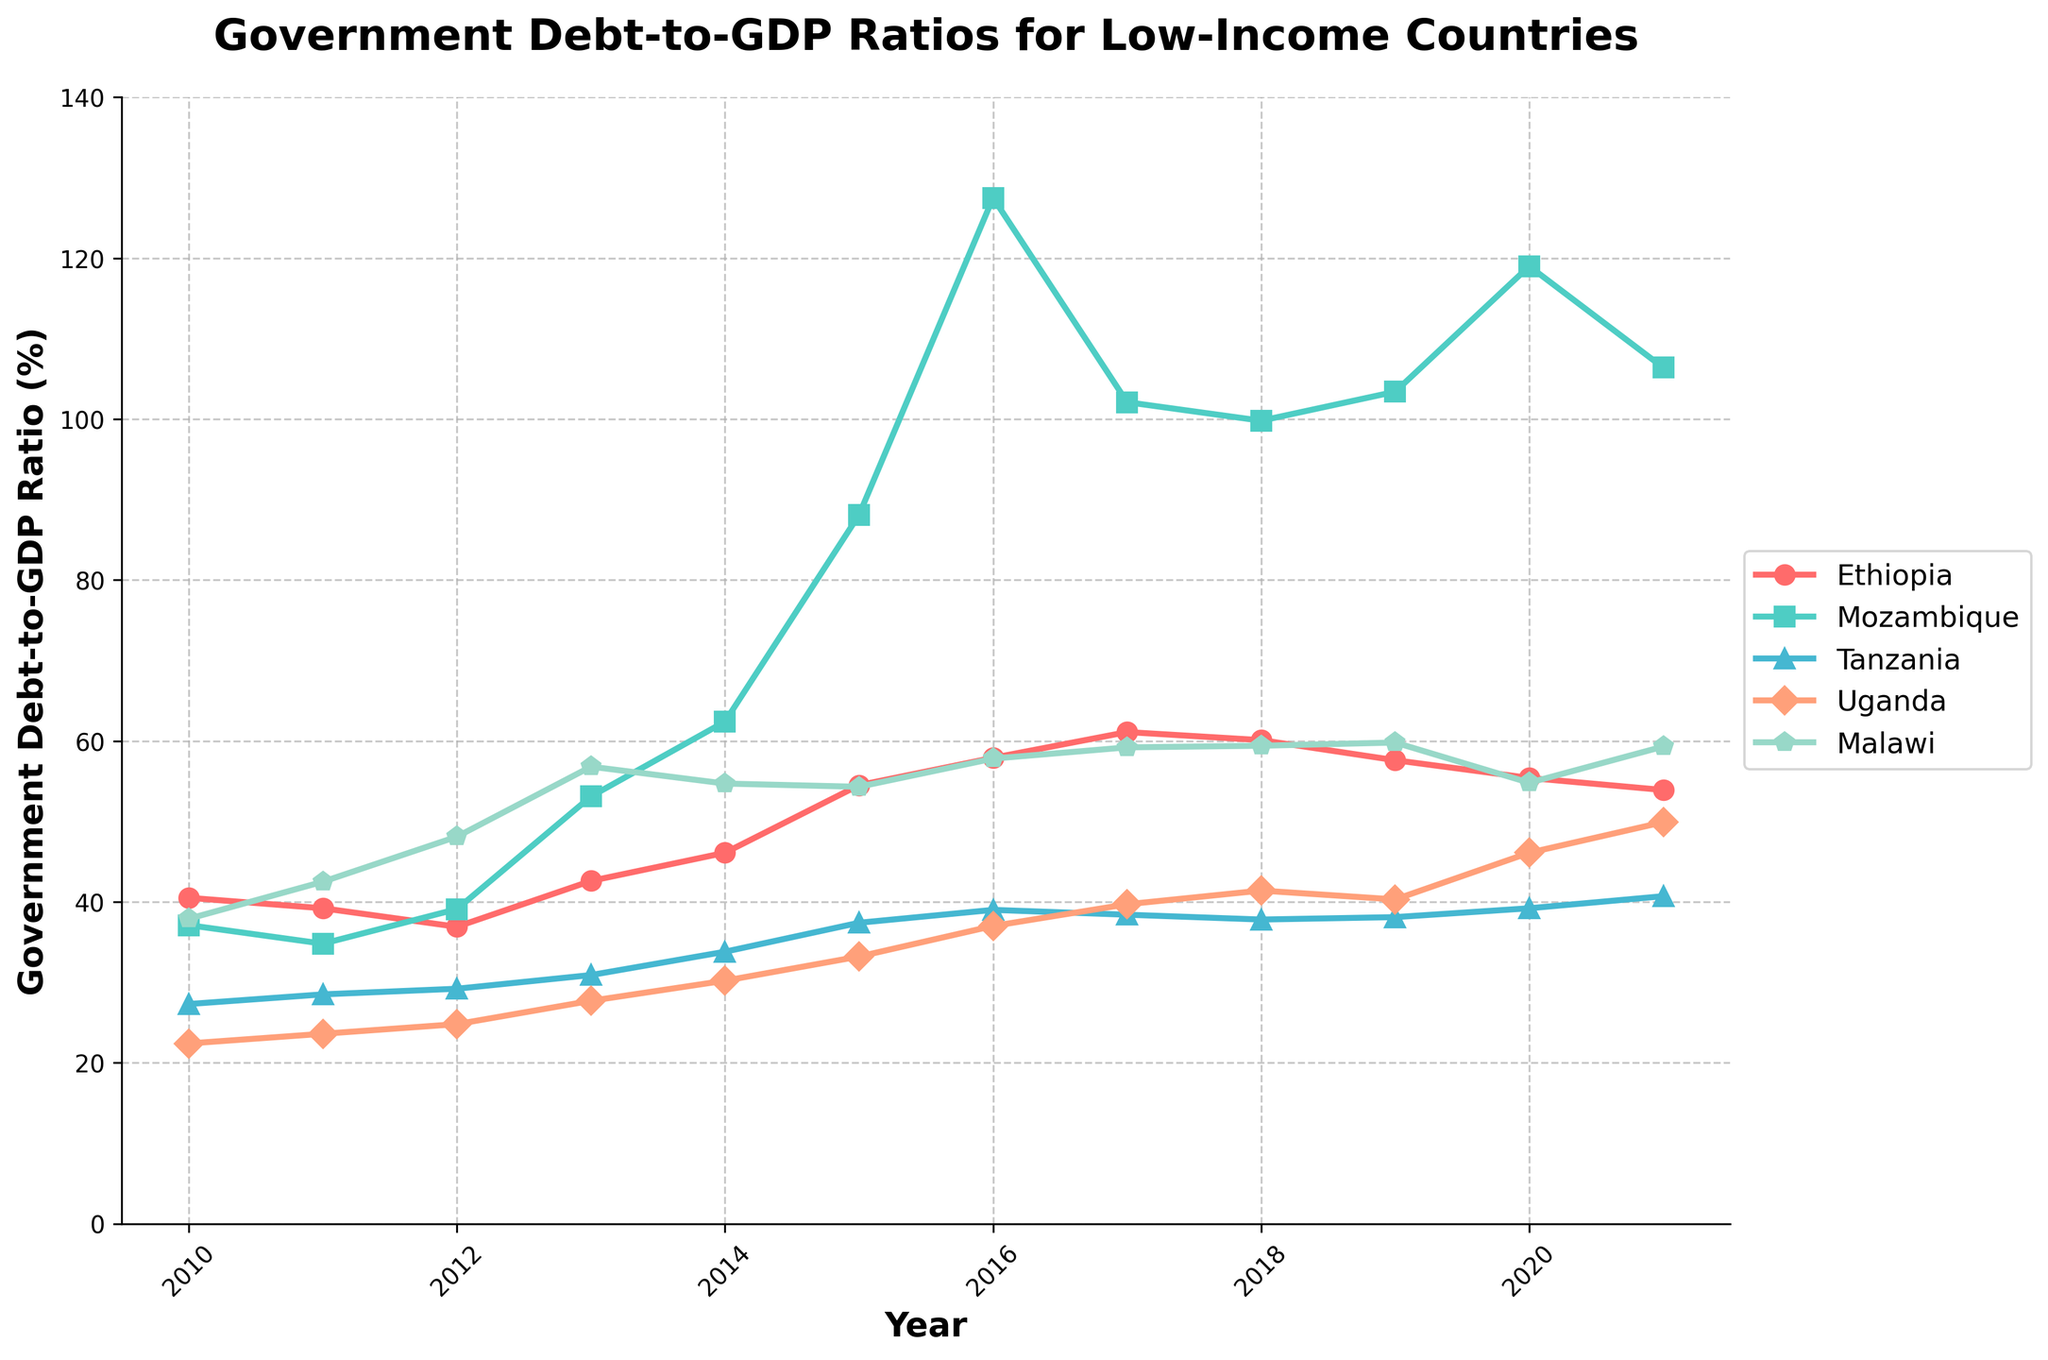What is the general trend in Mozambique's government debt-to-GDP ratio from 2010 to 2021? To identify the trend, observe the line for Mozambique. It starts from 37.1% in 2010, rises significantly to a peak of 127.5% in 2016, and then dips slightly but remains high at 106.4% in 2021. This shows a general increasing trend with a spike in the middle period.
Answer: Increasing with a significant spike Which country had the highest government debt-to-GDP ratio in 2015? Locate the data point for 2015 across all countries represented. Mozambique's line is the highest in 2015, reaching 88.1%.
Answer: Mozambique By how much did Ethiopia's debt-to-GDP ratio change from 2010 to 2021? Subtract the value in 2010 (40.5%) from the value in 2021 (53.9%). The change is 53.9 - 40.5 = 13.4%.
Answer: 13.4% Which country's debt-to-GDP ratio had the lowest peak value over the given period? Identify the peak value for each country by observing the highest point on each line. Tanzania's peak value is around 40.7% in 2021, which is the lowest peak compared to other countries.
Answer: Tanzania Compare the debt-to-GDP ratios of Uganda and Malawi in 2021. Which country had a higher ratio, and by how much? In 2021, Uganda’s ratio is 49.9%, and Malawi’s is 59.3%. Hence, Malawi’s ratio is higher. The difference is 59.3 - 49.9 = 9.4%.
Answer: Malawi by 9.4% What is the average debt-to-GDP ratio for Ethiopia from 2010 to 2021? Sum the debt-to-GDP ratios for Ethiopia from 2010 to 2021 (40.5 + 39.2 + 36.9 + 42.6 + 46.1 + 54.5 + 57.9 + 61.1 + 60.1 + 57.6 + 55.4 + 53.9) and divide by 12 (the number of years). The sum is 605.8, and the average is 605.8 / 12 ≈ 50.5%.
Answer: Approximately 50.5% Between which consecutive years did Malawi experience the largest increase in debt-to-GDP ratio? Examine the data points for Malawi and calculate the year-on-year increases. The largest increase is between 2012 (48.1%) and 2013 (56.8%). The increase is 56.8 - 48.1 = 8.7%.
Answer: 2012 to 2013 What color represents Uganda in the line chart? By visually inspecting the legend of the plot, the line representing Uganda is orange.
Answer: Orange How does the trend of Tanzania’s debt-to-GDP ratio from 2014 to 2021 compare to Uganda's trend for the same period? Observe the lines for Tanzania and Uganda between 2014 and 2021. Tanzania’s ratio shows a steady increase, whereas Uganda’s ratio increases continuously but at a slower rate after 2016.
Answer: Both increase, but Tanzania's is steadier Which country had the most volatile debt-to-GDP ratio from 2010 to 2021 and what indicates this volatility visually? Look for the line with the most fluctuations in value. Mozambique’s line shows significant spikes and drops, indicating a highly volatile debt-to-GDP ratio.
Answer: Mozambique 